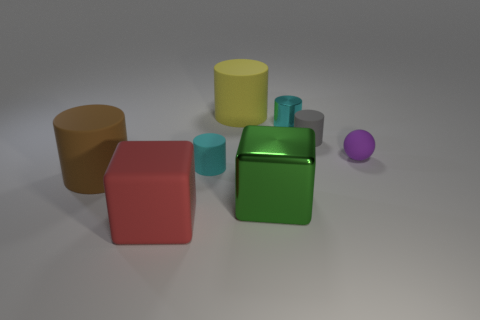There is a matte object that is the same color as the tiny metallic cylinder; what is its shape?
Provide a short and direct response. Cylinder. There is a metallic cylinder; is its color the same as the tiny cylinder that is on the left side of the big green cube?
Your response must be concise. Yes. What is the material of the big cylinder that is in front of the tiny rubber cylinder that is in front of the small gray matte object?
Offer a terse response. Rubber. Does the metallic object that is behind the green cube have the same shape as the tiny cyan object that is left of the large metal cube?
Ensure brevity in your answer.  Yes. Are there any gray things in front of the big green metal thing?
Your response must be concise. No. There is a small metal thing that is the same shape as the gray matte object; what color is it?
Make the answer very short. Cyan. Is there anything else that is the same shape as the small purple object?
Keep it short and to the point. No. There is a cyan cylinder in front of the tiny purple thing; what material is it?
Your response must be concise. Rubber. What size is the yellow rubber object that is the same shape as the tiny cyan rubber thing?
Your answer should be very brief. Large. What number of gray things have the same material as the small purple thing?
Keep it short and to the point. 1. 